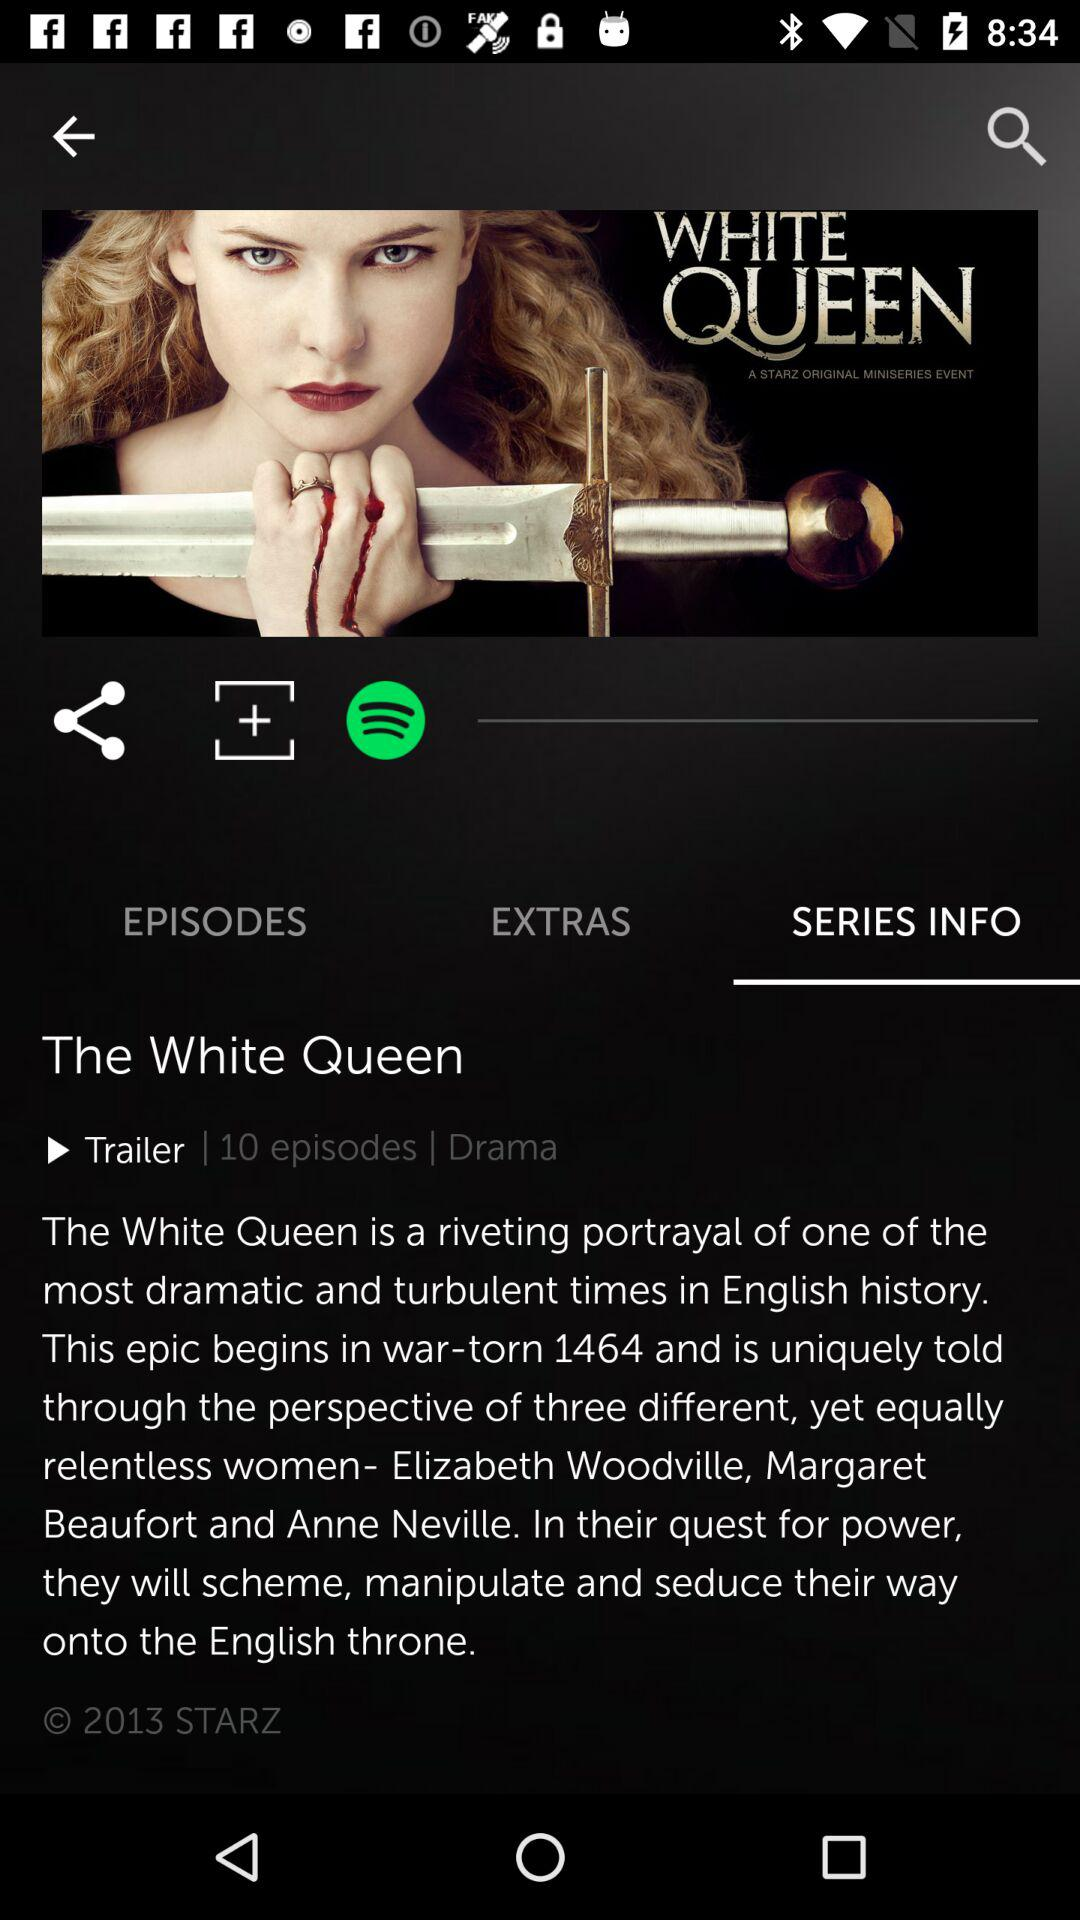What is the name of the serial? The name of the serial is "The White Queen". 